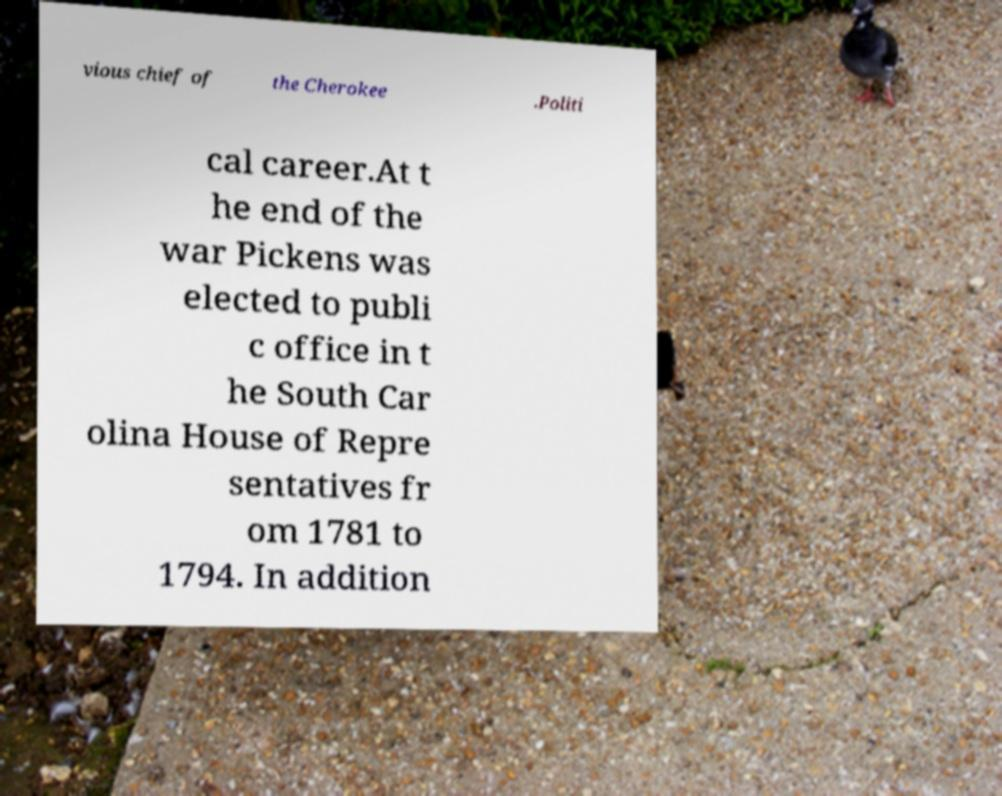There's text embedded in this image that I need extracted. Can you transcribe it verbatim? vious chief of the Cherokee .Politi cal career.At t he end of the war Pickens was elected to publi c office in t he South Car olina House of Repre sentatives fr om 1781 to 1794. In addition 